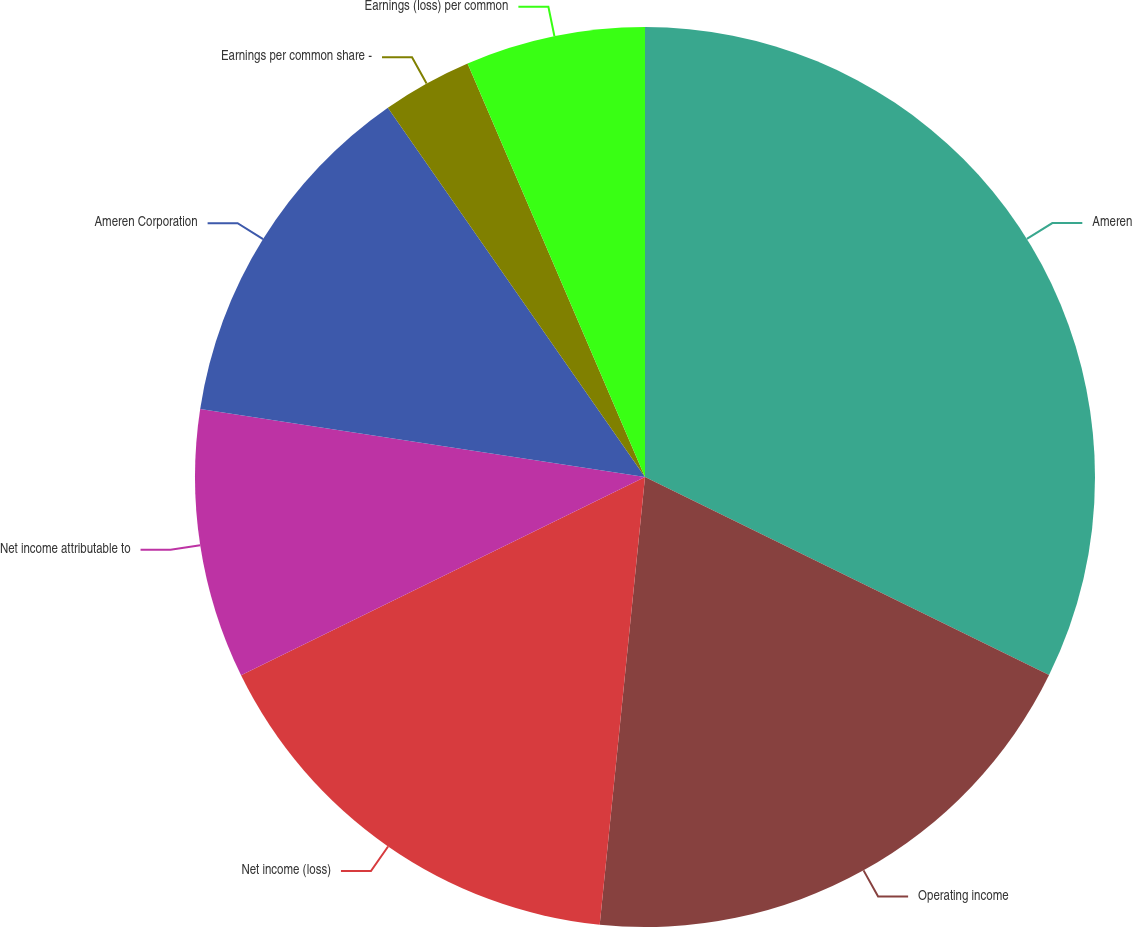Convert chart. <chart><loc_0><loc_0><loc_500><loc_500><pie_chart><fcel>Ameren<fcel>Operating income<fcel>Net income (loss)<fcel>Net income attributable to<fcel>Ameren Corporation<fcel>Earnings per common share -<fcel>Earnings (loss) per common<nl><fcel>32.25%<fcel>19.35%<fcel>16.13%<fcel>9.68%<fcel>12.9%<fcel>3.23%<fcel>6.45%<nl></chart> 